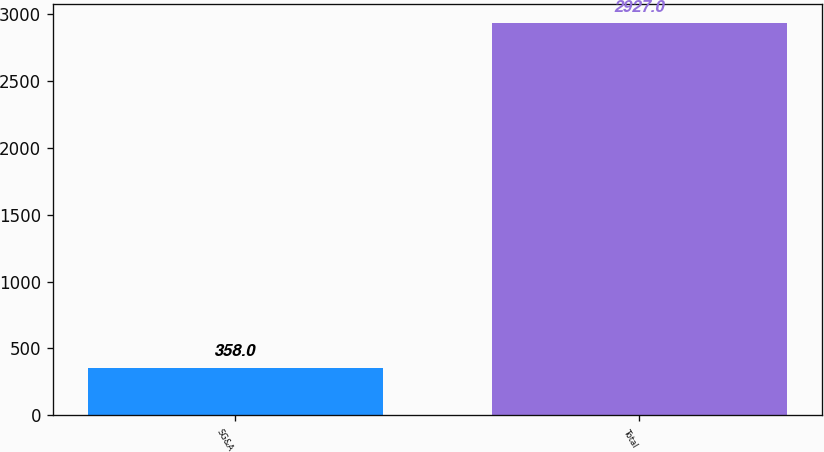Convert chart to OTSL. <chart><loc_0><loc_0><loc_500><loc_500><bar_chart><fcel>SG&A<fcel>Total<nl><fcel>358<fcel>2927<nl></chart> 